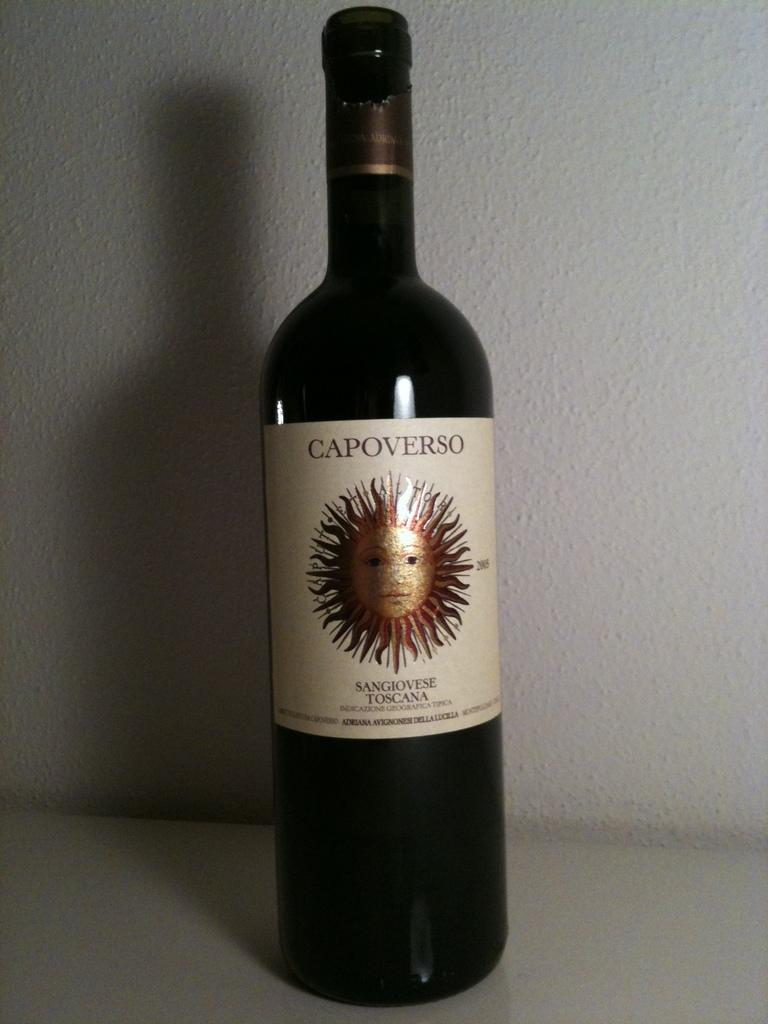<image>
Offer a succinct explanation of the picture presented. A bottle of Capoverso wine is in front of a white wall. 